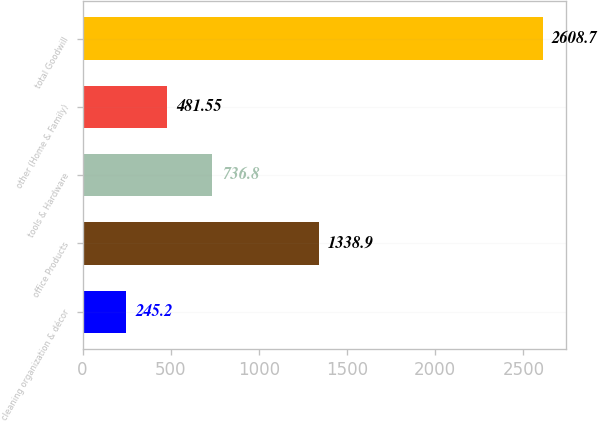Convert chart. <chart><loc_0><loc_0><loc_500><loc_500><bar_chart><fcel>cleaning organization & décor<fcel>office Products<fcel>tools & Hardware<fcel>other (Home & Family)<fcel>total Goodwill<nl><fcel>245.2<fcel>1338.9<fcel>736.8<fcel>481.55<fcel>2608.7<nl></chart> 